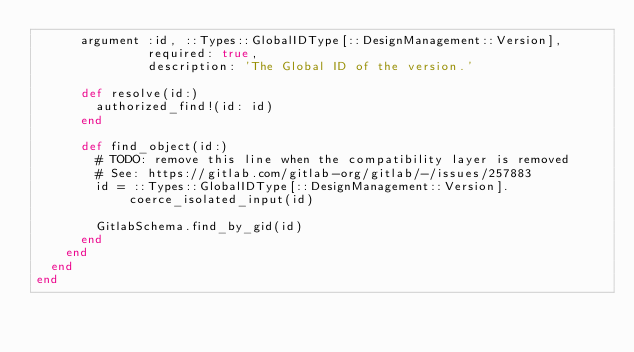Convert code to text. <code><loc_0><loc_0><loc_500><loc_500><_Ruby_>      argument :id, ::Types::GlobalIDType[::DesignManagement::Version],
               required: true,
               description: 'The Global ID of the version.'

      def resolve(id:)
        authorized_find!(id: id)
      end

      def find_object(id:)
        # TODO: remove this line when the compatibility layer is removed
        # See: https://gitlab.com/gitlab-org/gitlab/-/issues/257883
        id = ::Types::GlobalIDType[::DesignManagement::Version].coerce_isolated_input(id)

        GitlabSchema.find_by_gid(id)
      end
    end
  end
end
</code> 